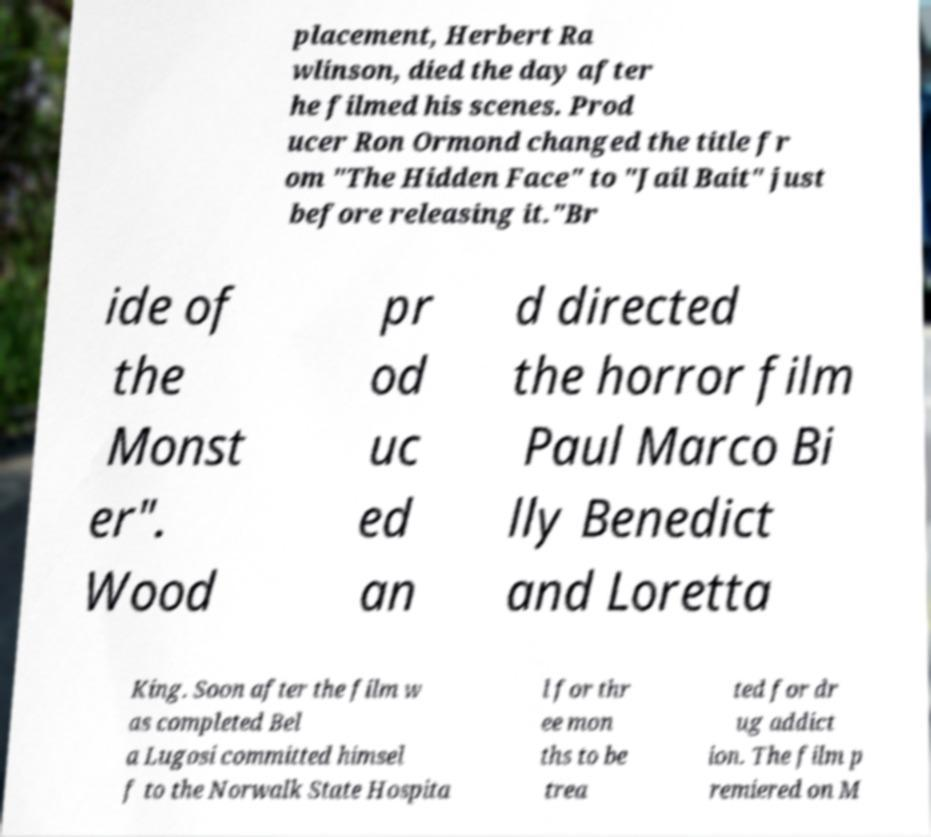Please identify and transcribe the text found in this image. placement, Herbert Ra wlinson, died the day after he filmed his scenes. Prod ucer Ron Ormond changed the title fr om "The Hidden Face" to "Jail Bait" just before releasing it."Br ide of the Monst er". Wood pr od uc ed an d directed the horror film Paul Marco Bi lly Benedict and Loretta King. Soon after the film w as completed Bel a Lugosi committed himsel f to the Norwalk State Hospita l for thr ee mon ths to be trea ted for dr ug addict ion. The film p remiered on M 